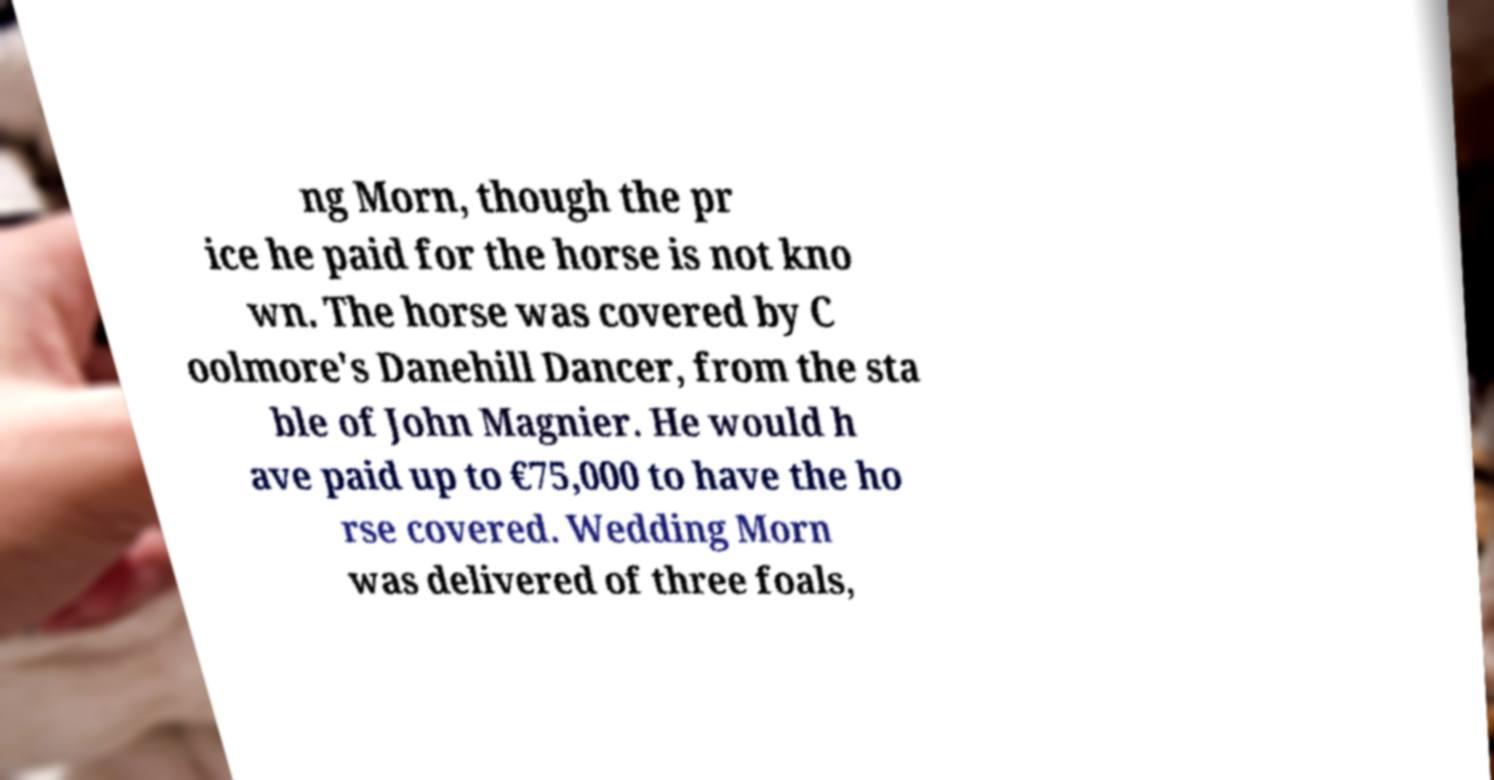There's text embedded in this image that I need extracted. Can you transcribe it verbatim? ng Morn, though the pr ice he paid for the horse is not kno wn. The horse was covered by C oolmore's Danehill Dancer, from the sta ble of John Magnier. He would h ave paid up to €75,000 to have the ho rse covered. Wedding Morn was delivered of three foals, 